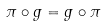Convert formula to latex. <formula><loc_0><loc_0><loc_500><loc_500>\pi \circ g = g \circ \pi</formula> 